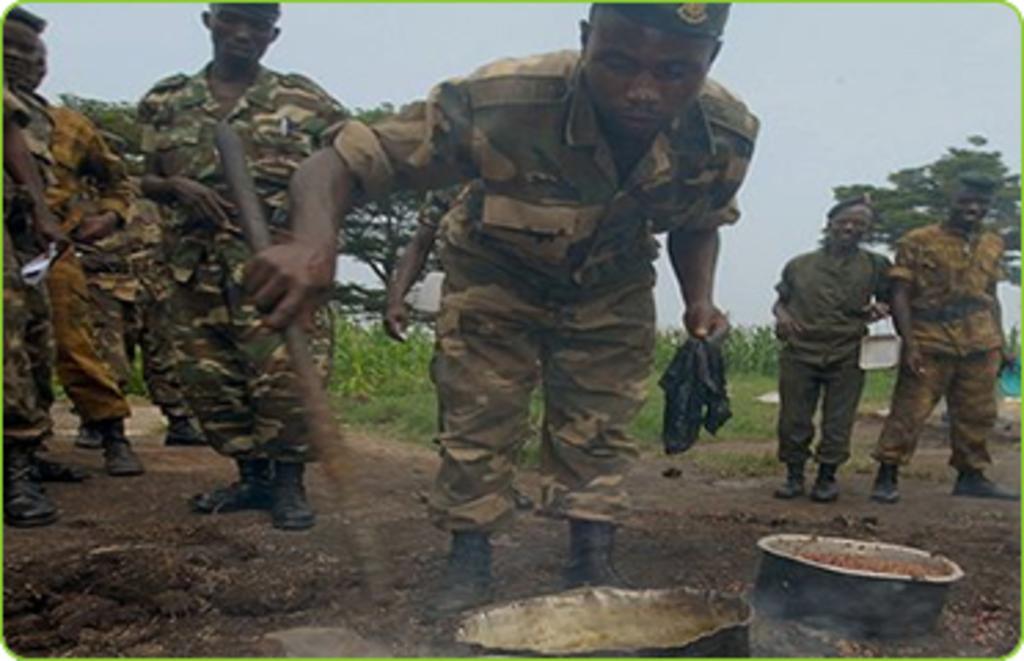Can you describe this image briefly? In this image I can see group of people are standing. This man is holding something in the hand. These people are wearing uniforms. Here I can see some some objects on the ground. In the background I can see trees grass and the sky. 